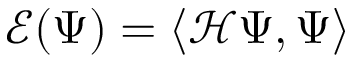Convert formula to latex. <formula><loc_0><loc_0><loc_500><loc_500>\mathcal { E } ( \Psi ) = \langle \mathcal { H } \Psi , \Psi \rangle</formula> 